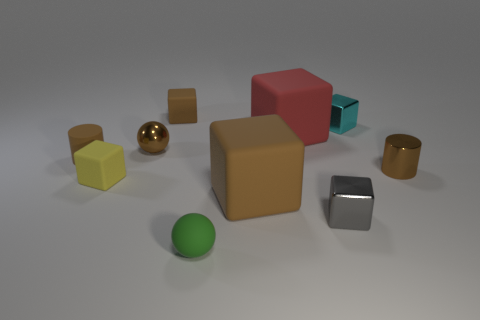What material is the small sphere that is the same color as the tiny rubber cylinder?
Make the answer very short. Metal. There is a small cylinder that is left of the tiny cyan metallic object; is its color the same as the small sphere that is behind the small brown metallic cylinder?
Ensure brevity in your answer.  Yes. Are there the same number of green rubber things behind the tiny cyan metallic object and rubber spheres?
Provide a short and direct response. No. Do the yellow rubber block and the rubber cylinder have the same size?
Your answer should be very brief. Yes. The rubber sphere that is the same size as the metal ball is what color?
Your answer should be very brief. Green. There is a brown metallic cylinder; is it the same size as the brown cylinder that is to the left of the small green object?
Keep it short and to the point. Yes. How many tiny balls have the same color as the small matte cylinder?
Provide a succinct answer. 1. What number of objects are either brown metal things or tiny brown rubber things behind the cyan object?
Your response must be concise. 3. Does the brown cube that is in front of the small yellow object have the same size as the ball that is to the left of the small green sphere?
Make the answer very short. No. Are there any cyan things that have the same material as the tiny gray object?
Make the answer very short. Yes. 